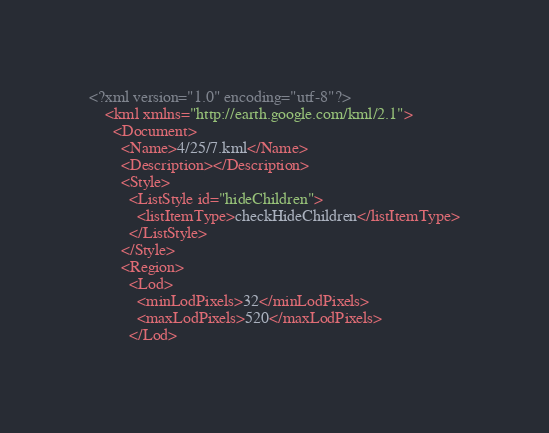<code> <loc_0><loc_0><loc_500><loc_500><_XML_><?xml version="1.0" encoding="utf-8"?>
	<kml xmlns="http://earth.google.com/kml/2.1">
	  <Document>
	    <Name>4/25/7.kml</Name>
	    <Description></Description>
	    <Style>
	      <ListStyle id="hideChildren">
	        <listItemType>checkHideChildren</listItemType>
	      </ListStyle>
	    </Style>
	    <Region>
	      <Lod>
	        <minLodPixels>32</minLodPixels>
	        <maxLodPixels>520</maxLodPixels>
	      </Lod></code> 